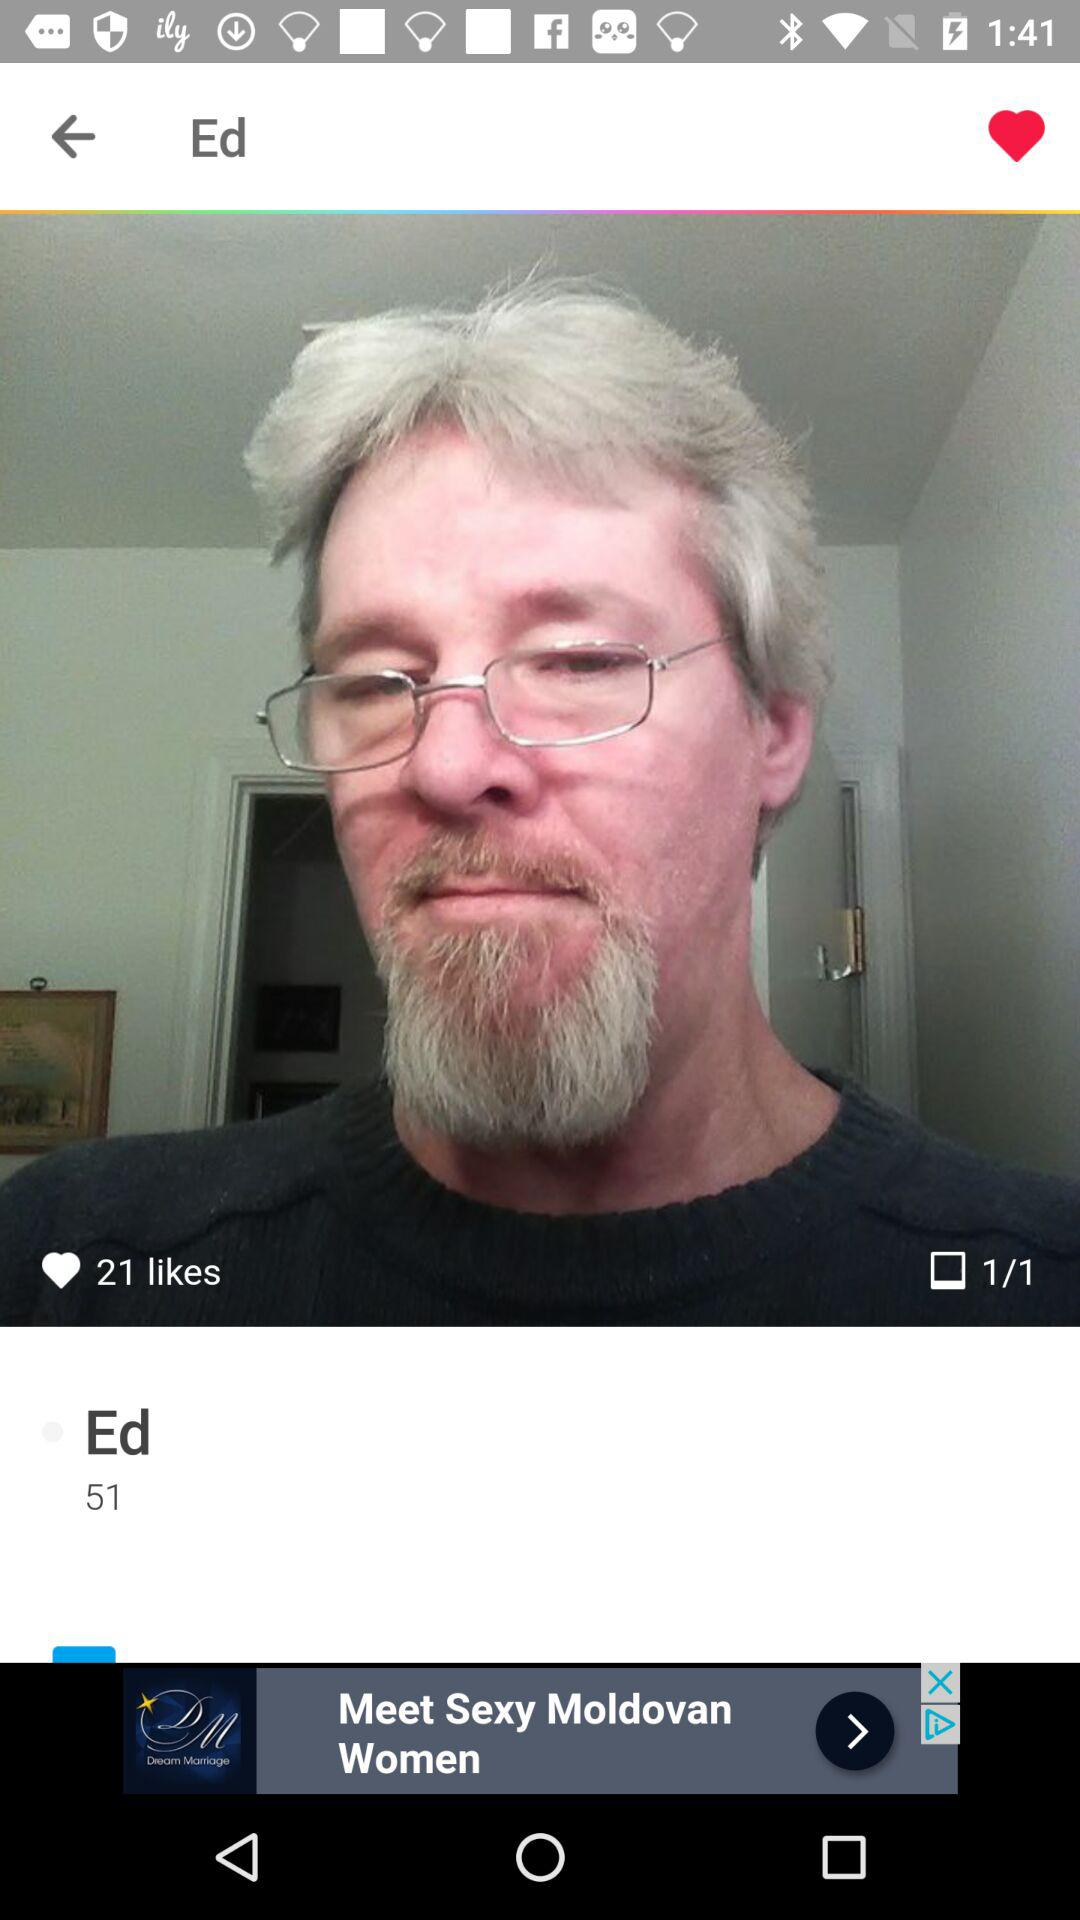How many likes on this? There are 21 likes. 